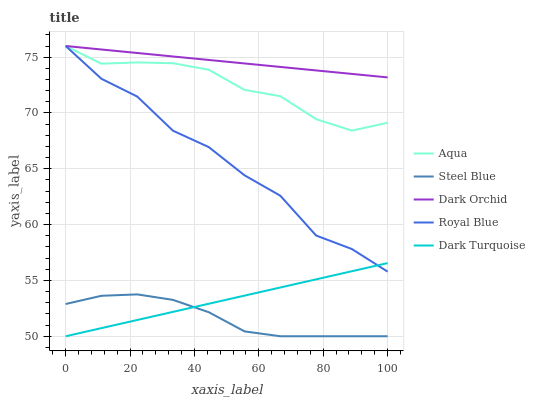Does Steel Blue have the minimum area under the curve?
Answer yes or no. Yes. Does Dark Orchid have the maximum area under the curve?
Answer yes or no. Yes. Does Aqua have the minimum area under the curve?
Answer yes or no. No. Does Aqua have the maximum area under the curve?
Answer yes or no. No. Is Dark Orchid the smoothest?
Answer yes or no. Yes. Is Royal Blue the roughest?
Answer yes or no. Yes. Is Aqua the smoothest?
Answer yes or no. No. Is Aqua the roughest?
Answer yes or no. No. Does Steel Blue have the lowest value?
Answer yes or no. Yes. Does Aqua have the lowest value?
Answer yes or no. No. Does Dark Orchid have the highest value?
Answer yes or no. Yes. Does Steel Blue have the highest value?
Answer yes or no. No. Is Dark Turquoise less than Dark Orchid?
Answer yes or no. Yes. Is Dark Orchid greater than Dark Turquoise?
Answer yes or no. Yes. Does Dark Turquoise intersect Royal Blue?
Answer yes or no. Yes. Is Dark Turquoise less than Royal Blue?
Answer yes or no. No. Is Dark Turquoise greater than Royal Blue?
Answer yes or no. No. Does Dark Turquoise intersect Dark Orchid?
Answer yes or no. No. 